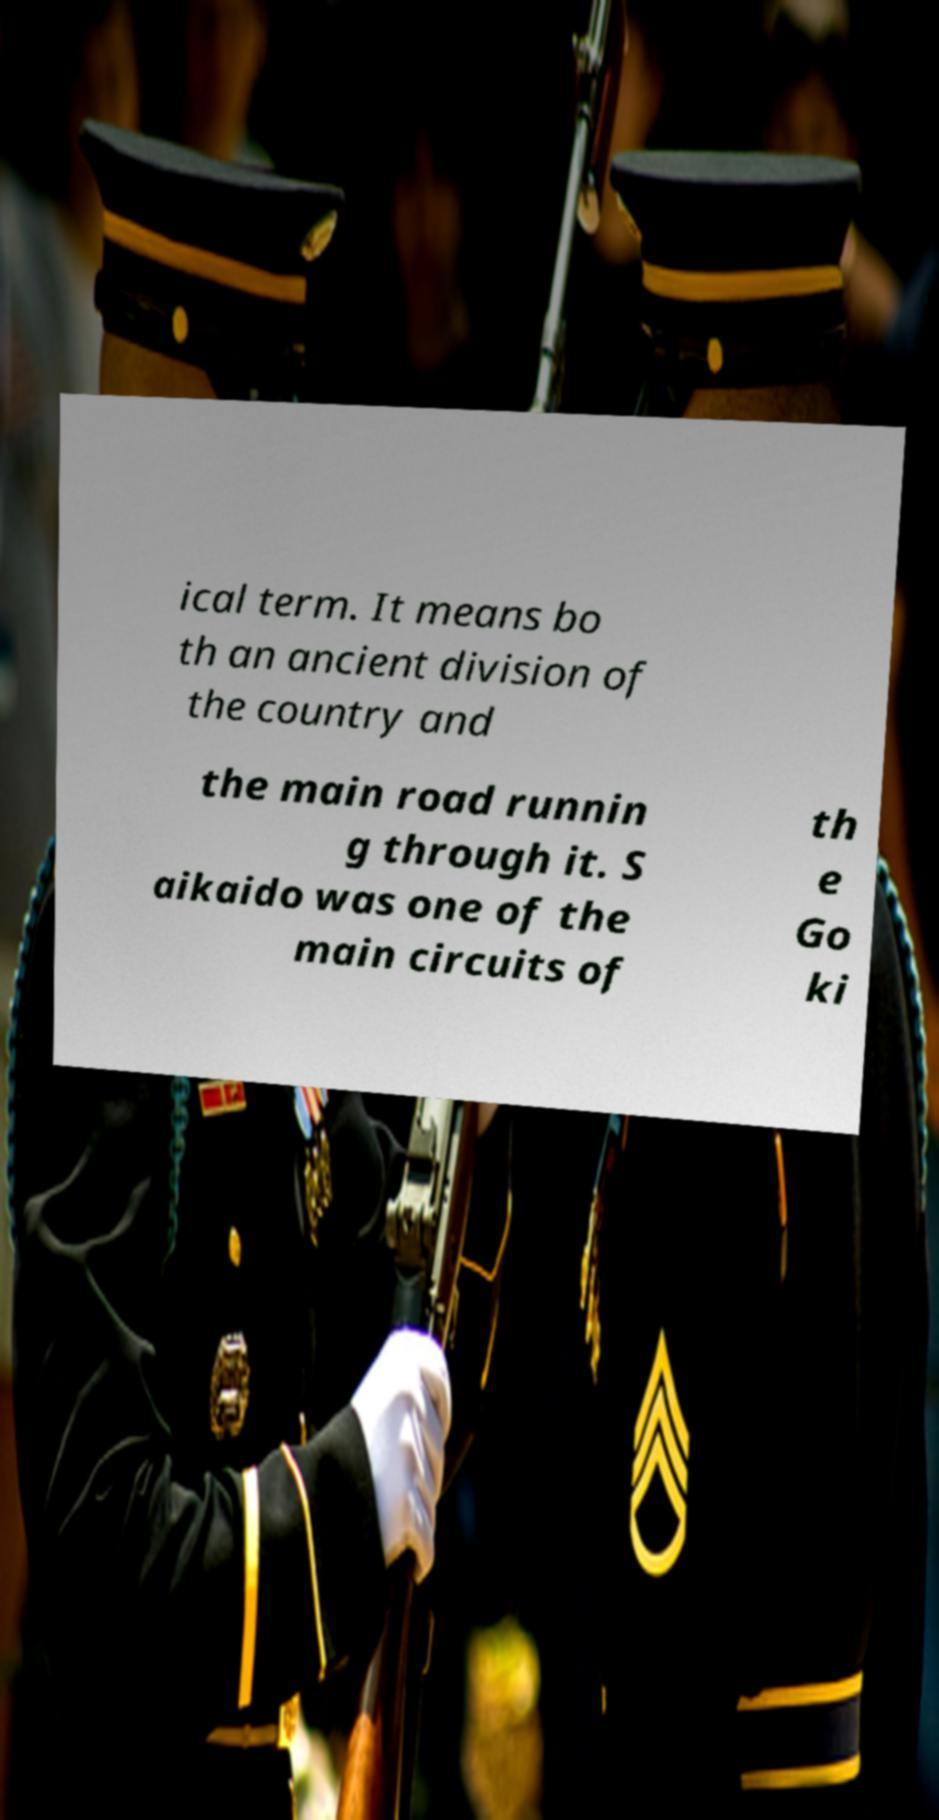Can you read and provide the text displayed in the image?This photo seems to have some interesting text. Can you extract and type it out for me? ical term. It means bo th an ancient division of the country and the main road runnin g through it. S aikaido was one of the main circuits of th e Go ki 